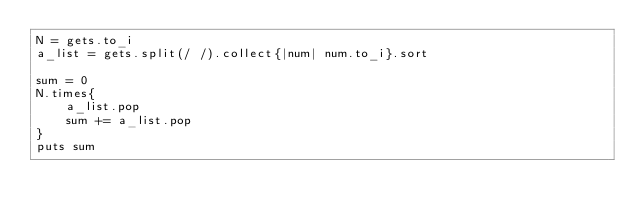<code> <loc_0><loc_0><loc_500><loc_500><_Ruby_>N = gets.to_i
a_list = gets.split(/ /).collect{|num| num.to_i}.sort

sum = 0
N.times{
	a_list.pop
	sum += a_list.pop
}
puts sum
</code> 